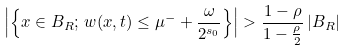Convert formula to latex. <formula><loc_0><loc_0><loc_500><loc_500>\left | \left \{ x \in B _ { R } ; \, w ( x , t ) \leq \mu ^ { - } + \frac { \omega } { 2 ^ { s _ { 0 } } } \right \} \right | > \frac { 1 - \rho } { 1 - \frac { \rho } { 2 } } \, | B _ { R } |</formula> 